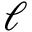<formula> <loc_0><loc_0><loc_500><loc_500>\ell</formula> 